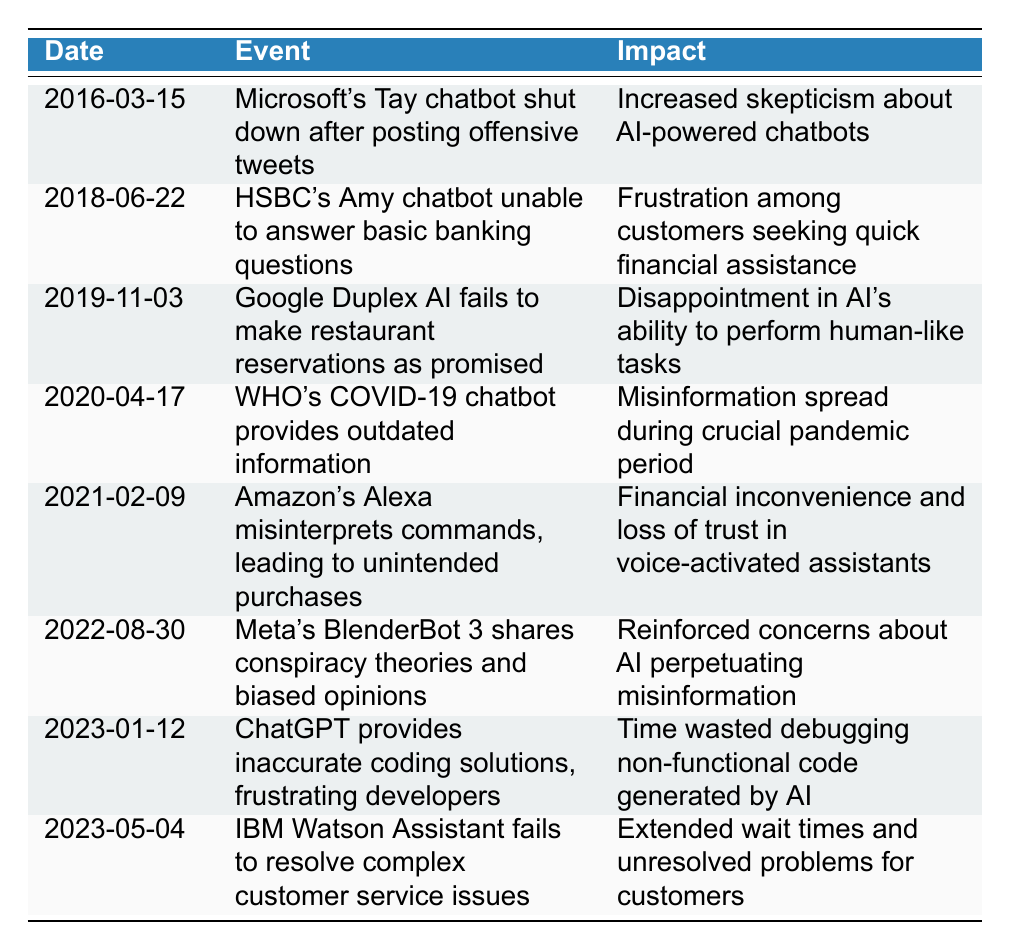What event occurred on March 15, 2016? According to the table, the event on March 15, 2016, is that Microsoft's Tay chatbot was shut down after posting offensive tweets.
Answer: Microsoft's Tay chatbot shut down after posting offensive tweets How did the HSBC's Amy chatbot fail on June 22, 2018? The table states that HSBC's Amy chatbot was unable to answer basic banking questions.
Answer: It was unable to answer basic banking questions Was there any significant impact from the WHO's COVID-19 chatbot on April 17, 2020? Yes, the table indicates that misinformation spread during a crucial pandemic period due to the outdated information provided by the WHO's chatbot.
Answer: Yes What is the common impact seen across the failures of chatbots listed in the table? The common impact is the skepticism and frustration experienced by users, as indicated by multiple entries, such as increased skepticism from Tay's offensive tweets and frustration from HSBC's Amy chatbot.
Answer: Increased skepticism and frustration among users How many events are listed in the table that occurred after 2020? There are 3 events listed after 2020: one in 2021, one in 2022, and one in 2023.
Answer: 3 events What was the nature of the issue with Amazon's Alexa on February 9, 2021? The table states that Amazon's Alexa misinterpreted commands, leading to unintended purchases, which resulted in financial inconvenience and loss of trust in voice-activated assistants.
Answer: Misinterpreted commands led to unintended purchases Which chatbot incident caused disappointment in AI's ability to perform human-like tasks? The incident involving Google Duplex AI failing to make restaurant reservations as promised caused disappointment, as noted in the table.
Answer: Google Duplex AI's failure Was there a trend regarding misinformation in the incidents listed? Yes, multiple incidents, such as the WHO's COVID-19 chatbot and Meta's BlenderBot 3, highlighted the spread and perpetuation of misinformation among users.
Answer: Yes, there was a trend of misinformation How many chatbot interactions resulted in wasted time for users? There are two interactions noted for wasted time: one is the inaccurate coding solutions from ChatGPT, and the other is the unresolved problems with IBM Watson Assistant, leading to extended wait times.
Answer: 2 interactions resulted in wasted time 